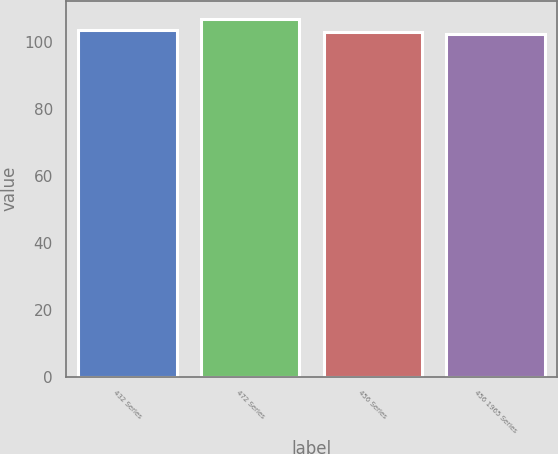<chart> <loc_0><loc_0><loc_500><loc_500><bar_chart><fcel>432 Series<fcel>472 Series<fcel>456 Series<fcel>456 1965 Series<nl><fcel>103.65<fcel>107<fcel>102.95<fcel>102.5<nl></chart> 